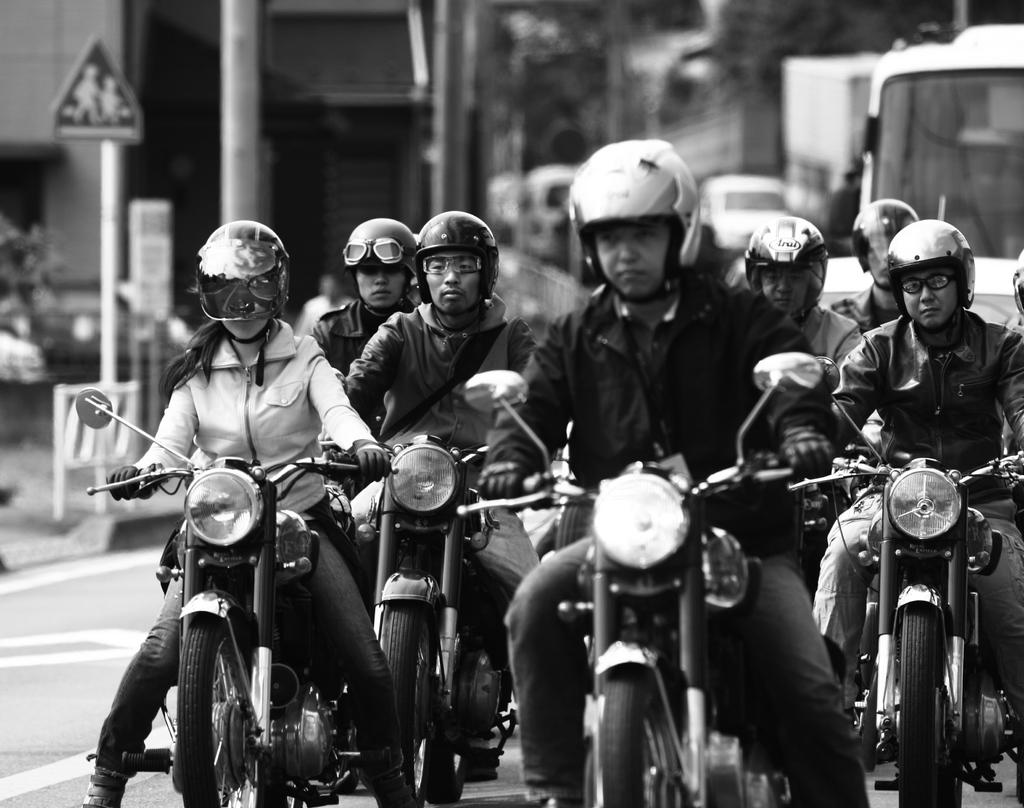What are the people in the image doing? There is a group of people riding motorcycles in the image. What else can be seen in the background of the image? There are vehicles visible in the background of the image. What type of structures are present in the image? There are sign boards and houses in the image. What color is the partner's paint on their voyage in the image? There is no partner, paint, or voyage present in the image. 